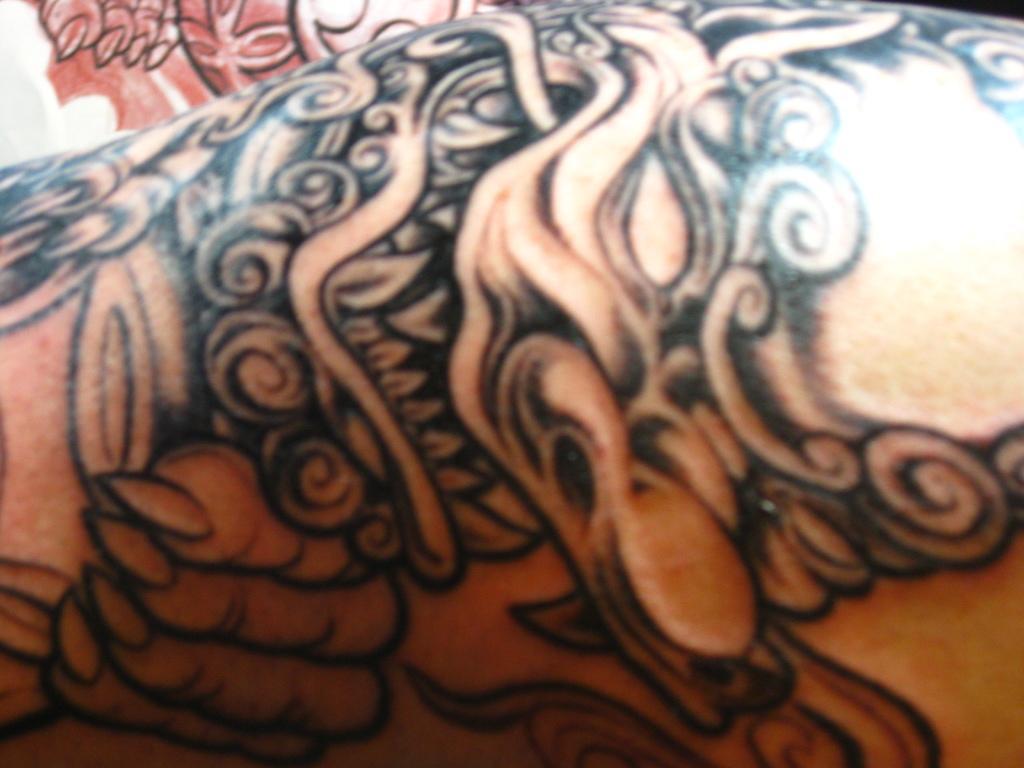In one or two sentences, can you explain what this image depicts? In the image we can see a human hand and on the hand there is a tattoo. 